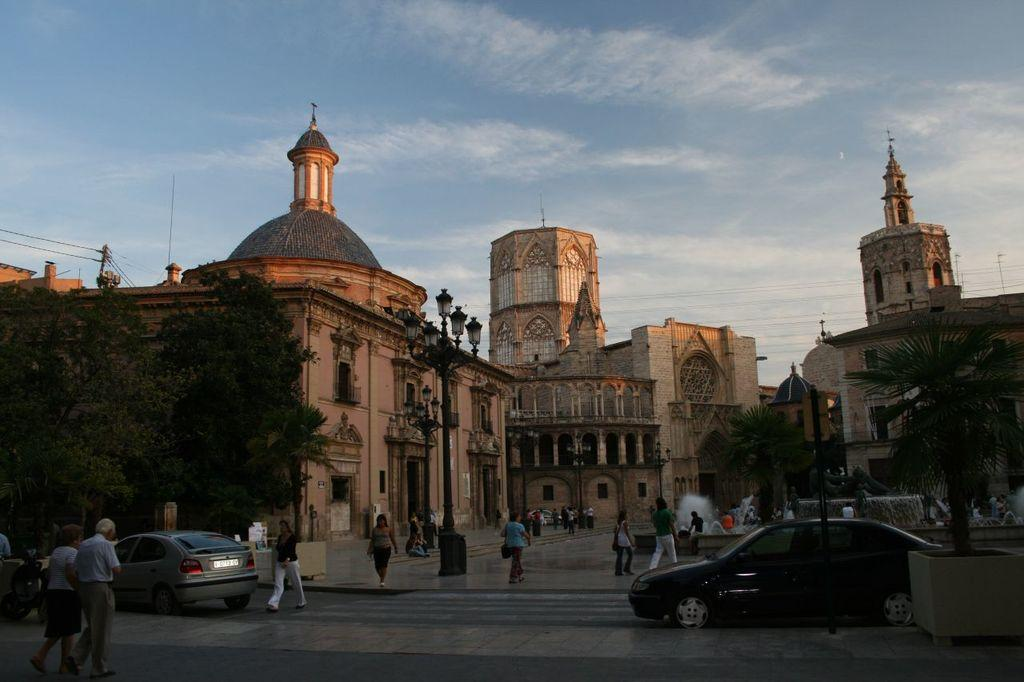What type of structures can be seen in the image? There are buildings in the image. What other natural elements are present in the image? There are trees in the image. What mode of transportation can be seen in the image? There are vehicles in the image. Are there any people present in the image? Yes, there is a group of people in the image. What type of illumination is visible in the image? There are lights in the image. What type of infrastructure is present in the image? There are cables in the image. What type of water feature can be seen in the image? There are water fountains in the image. What can be seen in the background of the image? The sky is visible in the background of the image. What type of fruit is being sold by the government in the image? There is no mention of fruit or the government in the image. What scent can be detected from the water fountains in the image? The image does not provide any information about the scent of the water fountains. 